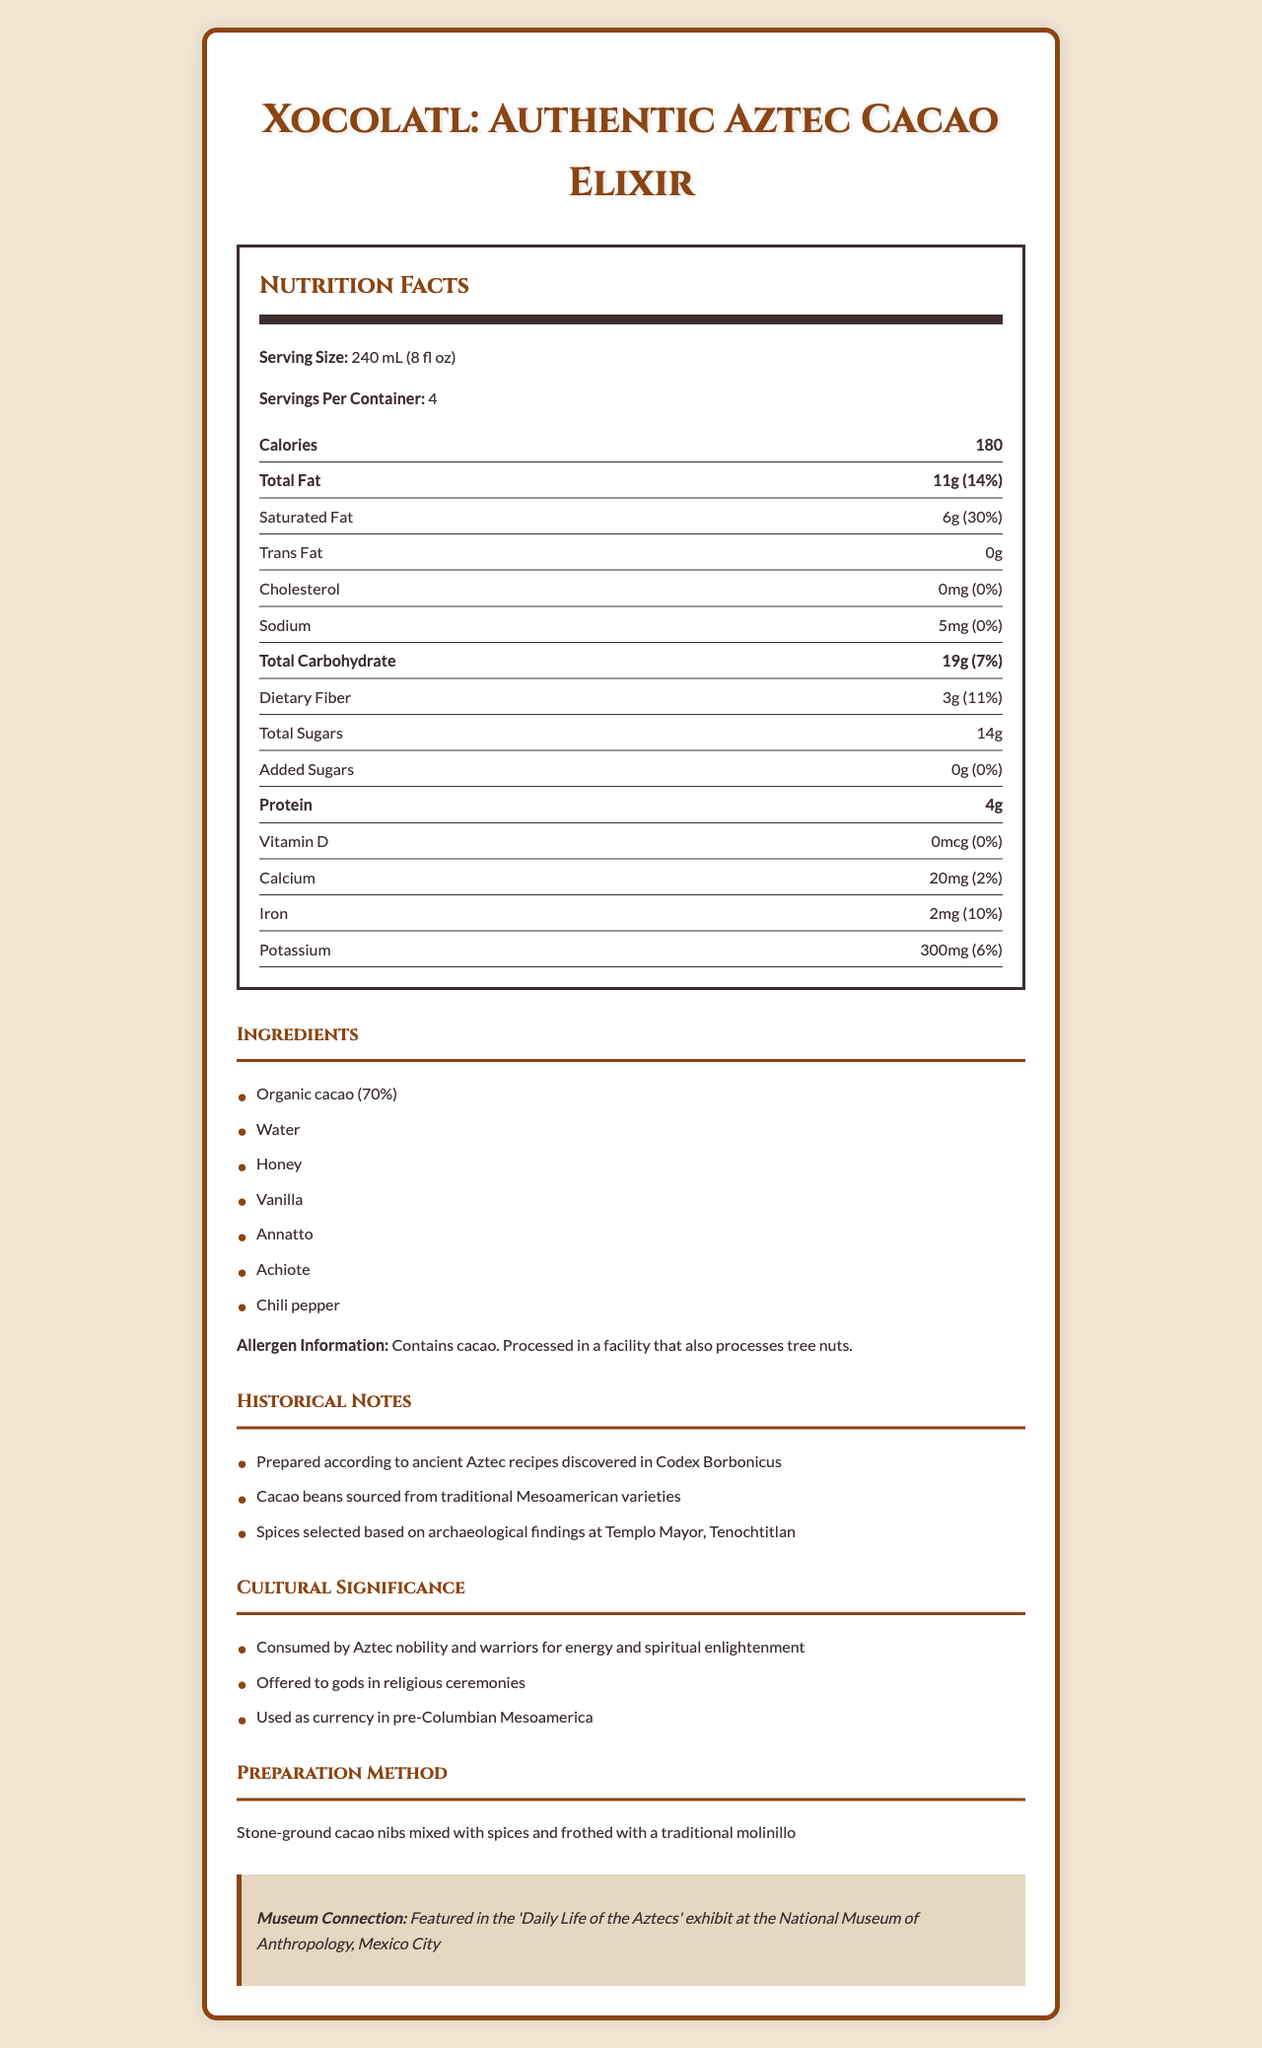what is the product name? The product name is clearly stated at the top of the document in a large, emphasized font.
Answer: Xocolatl: Authentic Aztec Cacao Elixir how much saturated fat is in one serving? The saturated fat content is listed under the nutrition facts section, showing both the amount in grams and the daily value percentage.
Answer: 6g (30%) what is the allergen information for this product? The allergen information is provided in the ingredients section of the document.
Answer: Contains cacao. Processed in a facility that also processes tree nuts. how many calories are in one serving? The calorie content per serving is listed prominently in the nutrition facts section.
Answer: 180 what is the daily value percentage of iron per serving? The iron daily value percentage is given in the nutrition facts section.
Answer: 10% which ingredient makes up the primary component of this drink? A. Water B. Honey C. Organic cacao The ingredients list shows "Organic cacao (70%)" as the primary component, indicating it is the main ingredient.
Answer: C how many servings are in one container? A. 2 B. 4 C. 6 The document lists 4 servings per container, as found in the serving information in the nutrition facts section.
Answer: B does this product contain trans fat? The nutrition facts section explicitly states "Trans Fat 0g".
Answer: No which historical document is mentioned in the historical notes? A. Codex Borbonicus B. Templo Mayor C. National Museum of Anthropology The historical notes mention that the drink is prepared according to ancient Aztec recipes discovered in the Codex Borbonicus.
Answer: A is this drink connected to any museum exhibit? The document mentions that the drink is featured in the 'Daily Life of the Aztecs' exhibit at the National Museum of Anthropology, Mexico City.
Answer: Yes summarize the main idea of the document. This document presents an in-depth overview of a traditional Aztec cacao drink, including its nutritional content, historical background, and cultural importance. It also highlights its authenticity and connection to museum exhibits.
Answer: The document provides comprehensive information about "Xocolatl: Authentic Aztec Cacao Elixir," including its nutritional facts, ingredients, allergen information, historical and cultural significance, preparation method, and connection to a museum exhibit. what spice is used in the preparation of this drink but not mentioned in the nutrition facts? The document does not provide a breakdown of individual spices in the nutrition facts section.
Answer: Cannot be determined what is the source of protein in this drink? The ingredient list and nutrition facts indicate that organic cacao, the primary component, likely provides the protein content.
Answer: Organic cacao what purpose did this drink serve in Aztec culture? The cultural significance section details these uses of the drink in Aztec culture.
Answer: Consumed by Aztec nobility and warriors for energy and spiritual enlightenment, offered to gods in ceremonies, and used as currency. 